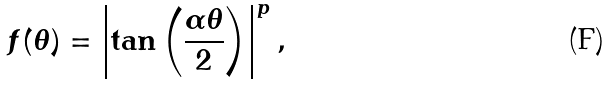Convert formula to latex. <formula><loc_0><loc_0><loc_500><loc_500>f ( \theta ) = \left | \tan \left ( \frac { \alpha \theta } { 2 } \right ) \right | ^ { p } ,</formula> 